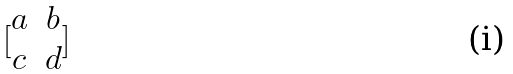<formula> <loc_0><loc_0><loc_500><loc_500>[ \begin{matrix} a & b \\ c & d \\ \end{matrix} ]</formula> 